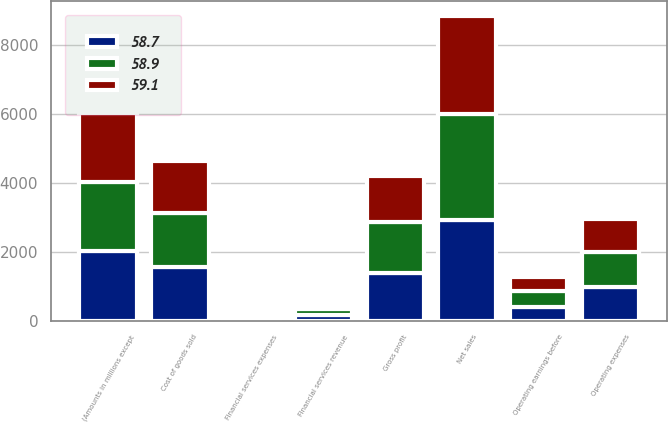Convert chart to OTSL. <chart><loc_0><loc_0><loc_500><loc_500><stacked_bar_chart><ecel><fcel>(Amounts in millions except<fcel>Net sales<fcel>Cost of goods sold<fcel>Gross profit<fcel>Operating expenses<fcel>Operating earnings before<fcel>Financial services revenue<fcel>Financial services expenses<nl><fcel>58.9<fcel>2013<fcel>3056.5<fcel>1583.6<fcel>1472.9<fcel>1012.4<fcel>460.5<fcel>181<fcel>55.3<nl><fcel>58.7<fcel>2012<fcel>2937.9<fcel>1547.9<fcel>1390<fcel>980.3<fcel>409.7<fcel>161.3<fcel>54.6<nl><fcel>59.1<fcel>2011<fcel>2854.2<fcel>1516.3<fcel>1337.9<fcel>953.7<fcel>384.2<fcel>124.3<fcel>51.4<nl></chart> 